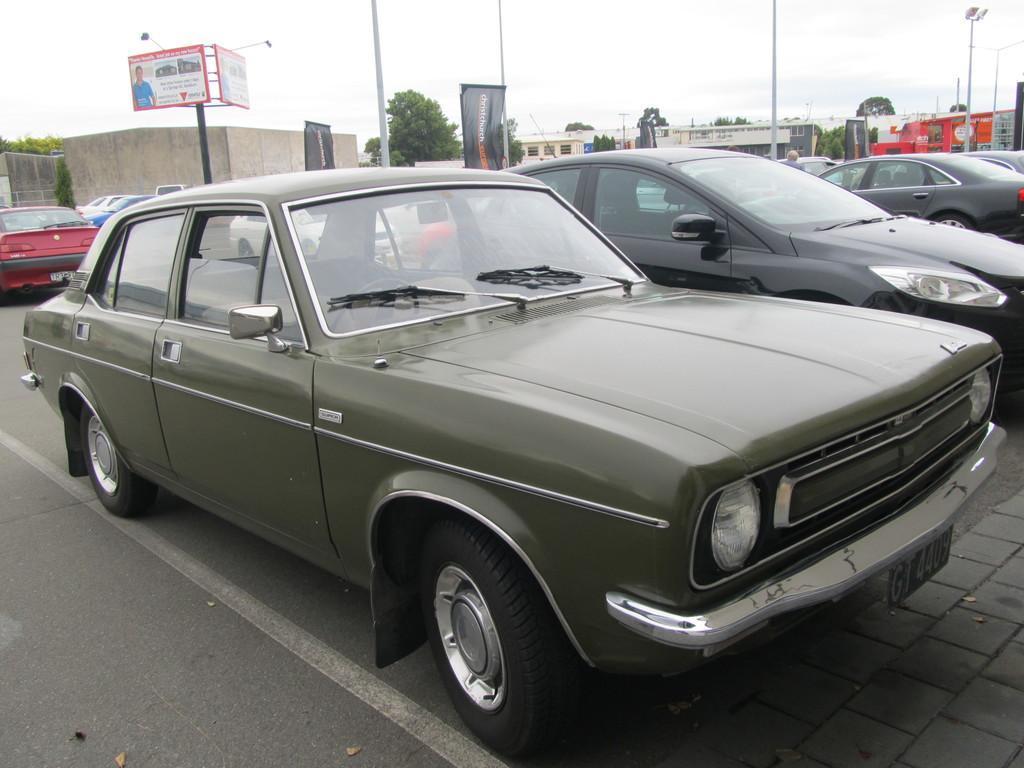Describe this image in one or two sentences. In this image I can see few vehicles. In front the vehicle is in gray color, background I can see few plants in green color. I can also see few banners attached to the poles and I can also see few light poles and the sky is in white color. 